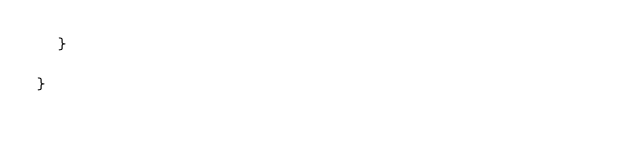<code> <loc_0><loc_0><loc_500><loc_500><_Java_>	}

}
</code> 